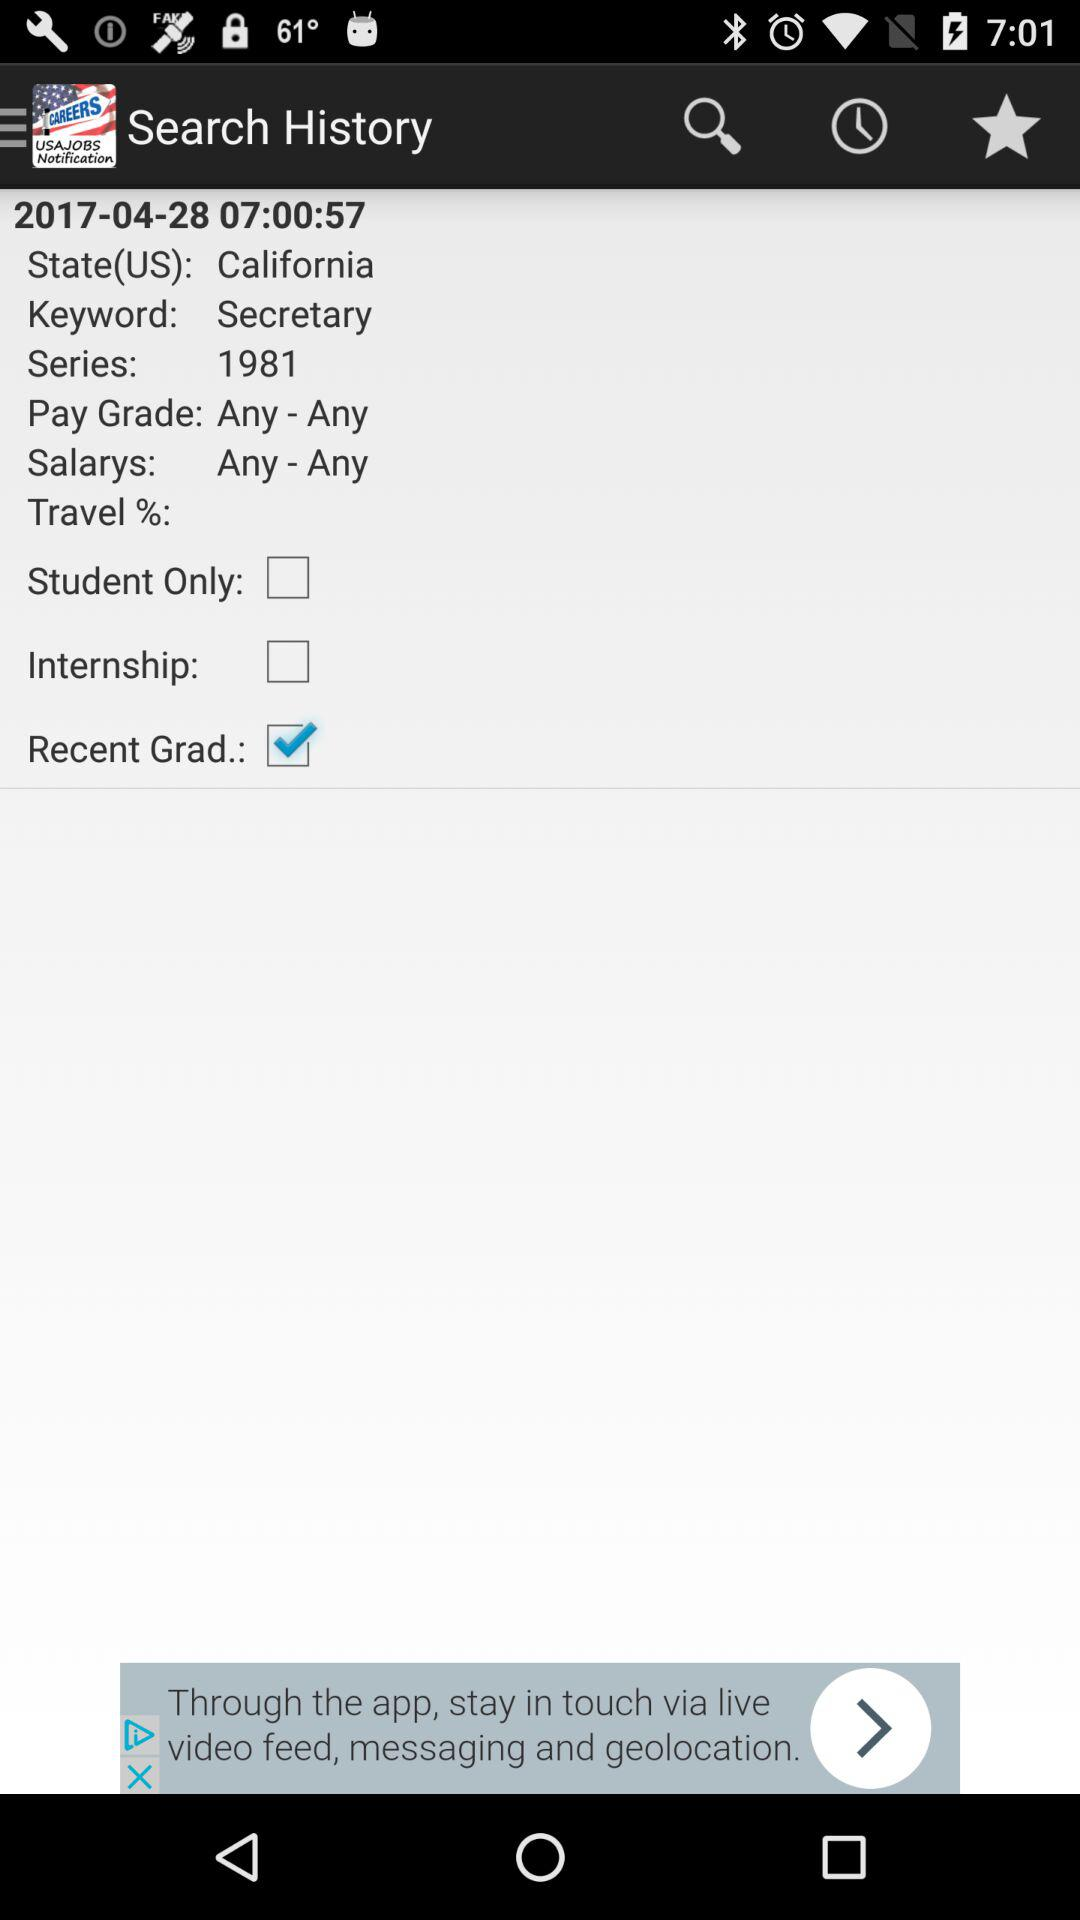What's the selected option? The selected option is "Recent Grad". 